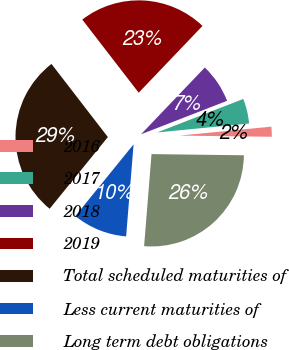<chart> <loc_0><loc_0><loc_500><loc_500><pie_chart><fcel>2016<fcel>2017<fcel>2018<fcel>2019<fcel>Total scheduled maturities of<fcel>Less current maturities of<fcel>Long term debt obligations<nl><fcel>1.75%<fcel>4.36%<fcel>6.96%<fcel>22.59%<fcel>28.69%<fcel>9.57%<fcel>26.08%<nl></chart> 